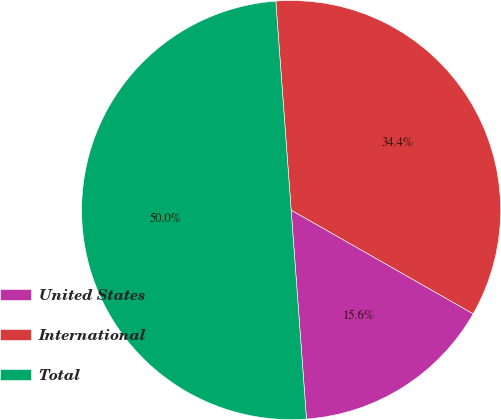<chart> <loc_0><loc_0><loc_500><loc_500><pie_chart><fcel>United States<fcel>International<fcel>Total<nl><fcel>15.59%<fcel>34.41%<fcel>50.0%<nl></chart> 